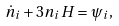Convert formula to latex. <formula><loc_0><loc_0><loc_500><loc_500>\dot { n } _ { i } + 3 n _ { i } H = \psi _ { i } ,</formula> 